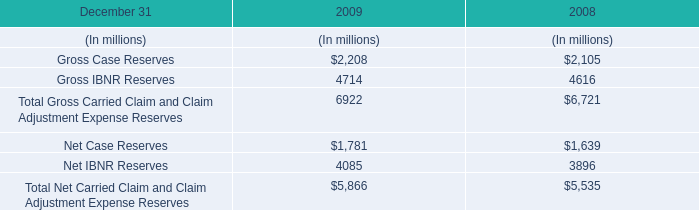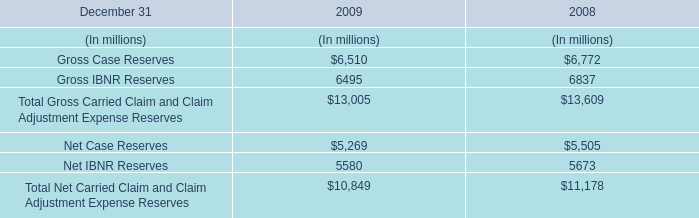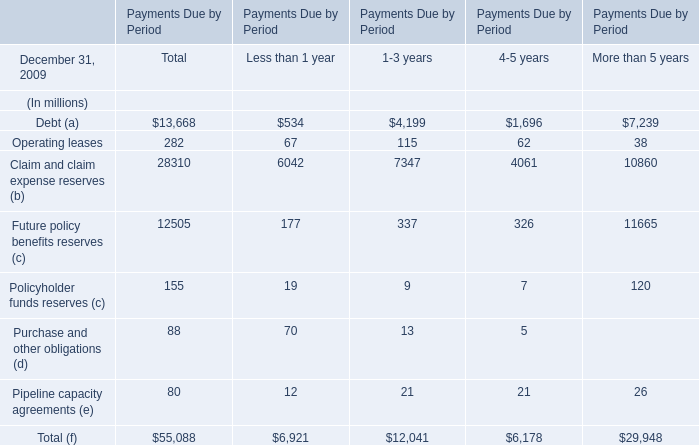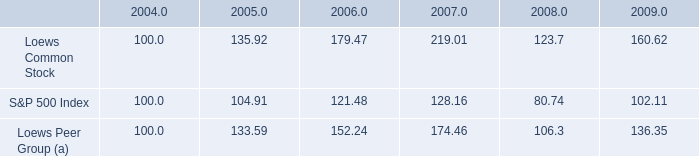what is the return on investment for s&p500 from 2007 to 2008? 
Computations: ((80.74 - 128.16) / 128.16)
Answer: -0.37001. 